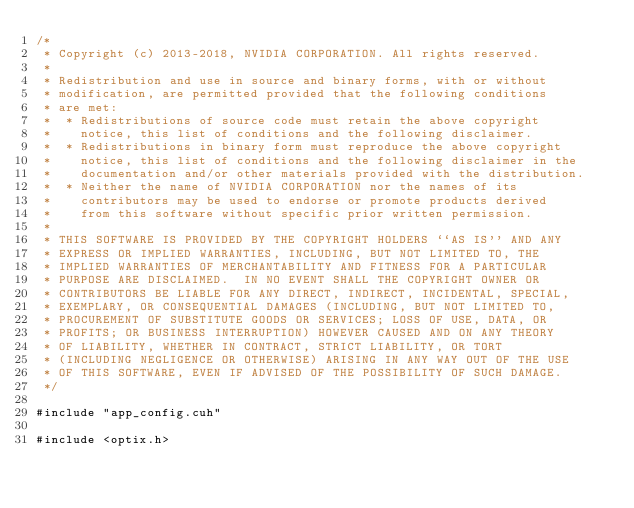<code> <loc_0><loc_0><loc_500><loc_500><_Cuda_>/*
 * Copyright (c) 2013-2018, NVIDIA CORPORATION. All rights reserved.
 *
 * Redistribution and use in source and binary forms, with or without
 * modification, are permitted provided that the following conditions
 * are met:
 *  * Redistributions of source code must retain the above copyright
 *    notice, this list of conditions and the following disclaimer.
 *  * Redistributions in binary form must reproduce the above copyright
 *    notice, this list of conditions and the following disclaimer in the
 *    documentation and/or other materials provided with the distribution.
 *  * Neither the name of NVIDIA CORPORATION nor the names of its
 *    contributors may be used to endorse or promote products derived
 *    from this software without specific prior written permission.
 *
 * THIS SOFTWARE IS PROVIDED BY THE COPYRIGHT HOLDERS ``AS IS'' AND ANY
 * EXPRESS OR IMPLIED WARRANTIES, INCLUDING, BUT NOT LIMITED TO, THE
 * IMPLIED WARRANTIES OF MERCHANTABILITY AND FITNESS FOR A PARTICULAR
 * PURPOSE ARE DISCLAIMED.  IN NO EVENT SHALL THE COPYRIGHT OWNER OR
 * CONTRIBUTORS BE LIABLE FOR ANY DIRECT, INDIRECT, INCIDENTAL, SPECIAL,
 * EXEMPLARY, OR CONSEQUENTIAL DAMAGES (INCLUDING, BUT NOT LIMITED TO,
 * PROCUREMENT OF SUBSTITUTE GOODS OR SERVICES; LOSS OF USE, DATA, OR
 * PROFITS; OR BUSINESS INTERRUPTION) HOWEVER CAUSED AND ON ANY THEORY
 * OF LIABILITY, WHETHER IN CONTRACT, STRICT LIABILITY, OR TORT
 * (INCLUDING NEGLIGENCE OR OTHERWISE) ARISING IN ANY WAY OUT OF THE USE
 * OF THIS SOFTWARE, EVEN IF ADVISED OF THE POSSIBILITY OF SUCH DAMAGE.
 */

#include "app_config.cuh"

#include <optix.h></code> 